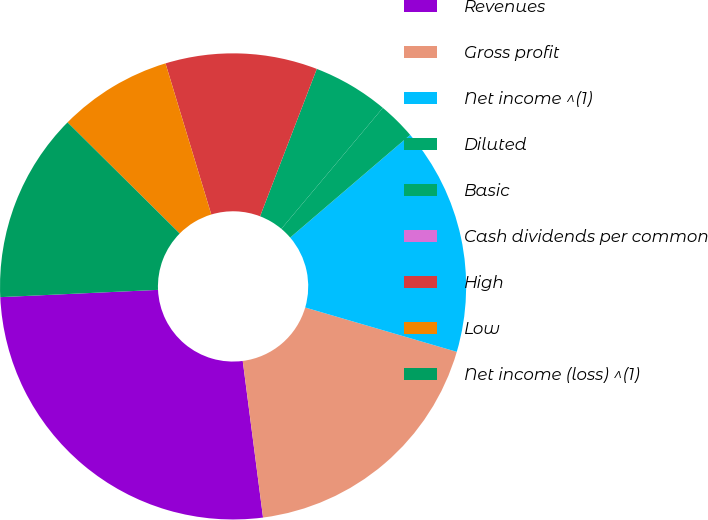Convert chart to OTSL. <chart><loc_0><loc_0><loc_500><loc_500><pie_chart><fcel>Revenues<fcel>Gross profit<fcel>Net income ^(1)<fcel>Diluted<fcel>Basic<fcel>Cash dividends per common<fcel>High<fcel>Low<fcel>Net income (loss) ^(1)<nl><fcel>26.32%<fcel>18.42%<fcel>15.79%<fcel>2.63%<fcel>5.26%<fcel>0.0%<fcel>10.53%<fcel>7.89%<fcel>13.16%<nl></chart> 